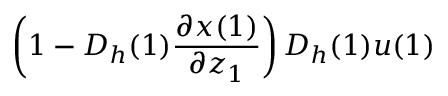Convert formula to latex. <formula><loc_0><loc_0><loc_500><loc_500>\left ( 1 - D _ { h } ( 1 ) \frac { \partial x ( 1 ) } { \partial z _ { 1 } } \right ) D _ { h } ( 1 ) u ( 1 )</formula> 